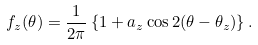Convert formula to latex. <formula><loc_0><loc_0><loc_500><loc_500>f _ { z } ( \theta ) = \frac { 1 } { 2 \pi } \left \{ 1 + a _ { z } \cos 2 ( \theta - \theta _ { z } ) \right \} .</formula> 